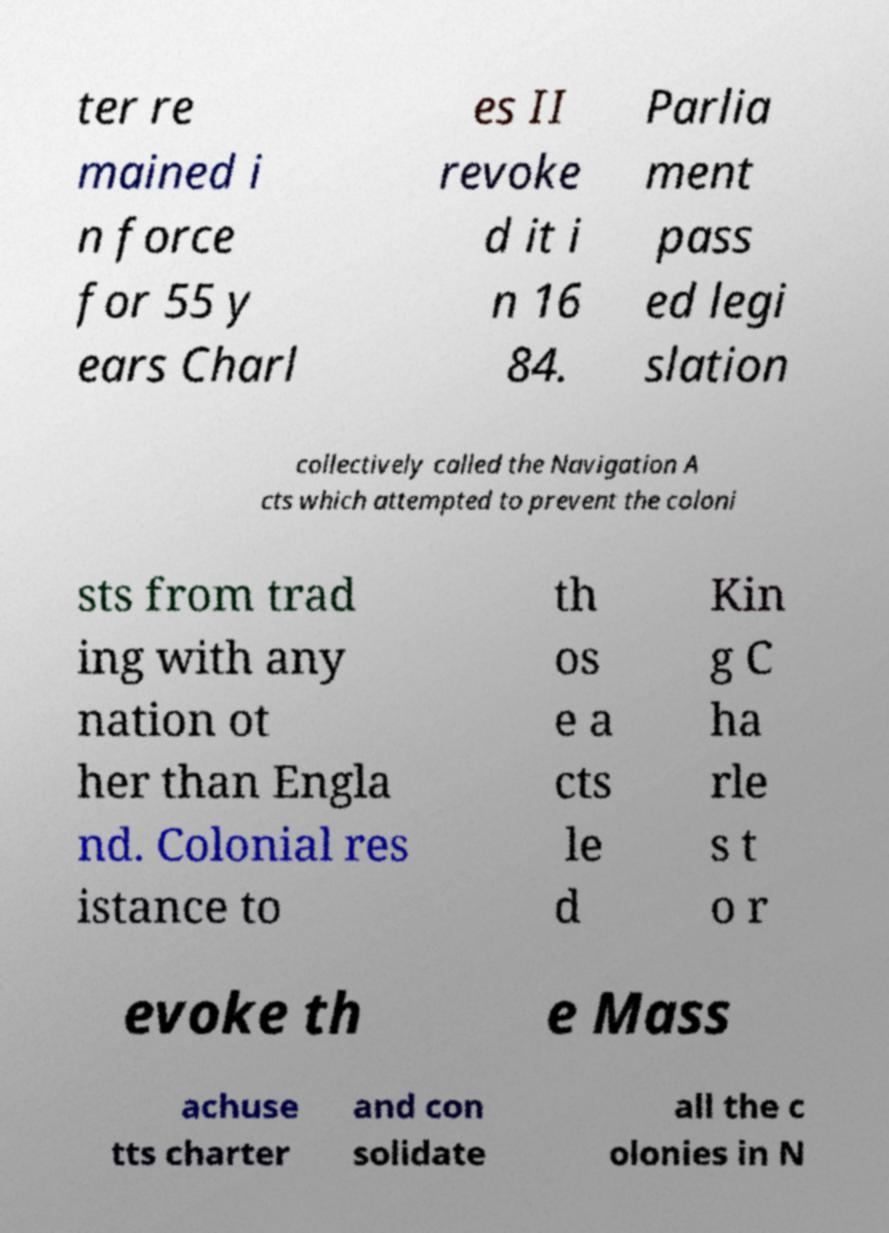Can you read and provide the text displayed in the image?This photo seems to have some interesting text. Can you extract and type it out for me? ter re mained i n force for 55 y ears Charl es II revoke d it i n 16 84. Parlia ment pass ed legi slation collectively called the Navigation A cts which attempted to prevent the coloni sts from trad ing with any nation ot her than Engla nd. Colonial res istance to th os e a cts le d Kin g C ha rle s t o r evoke th e Mass achuse tts charter and con solidate all the c olonies in N 